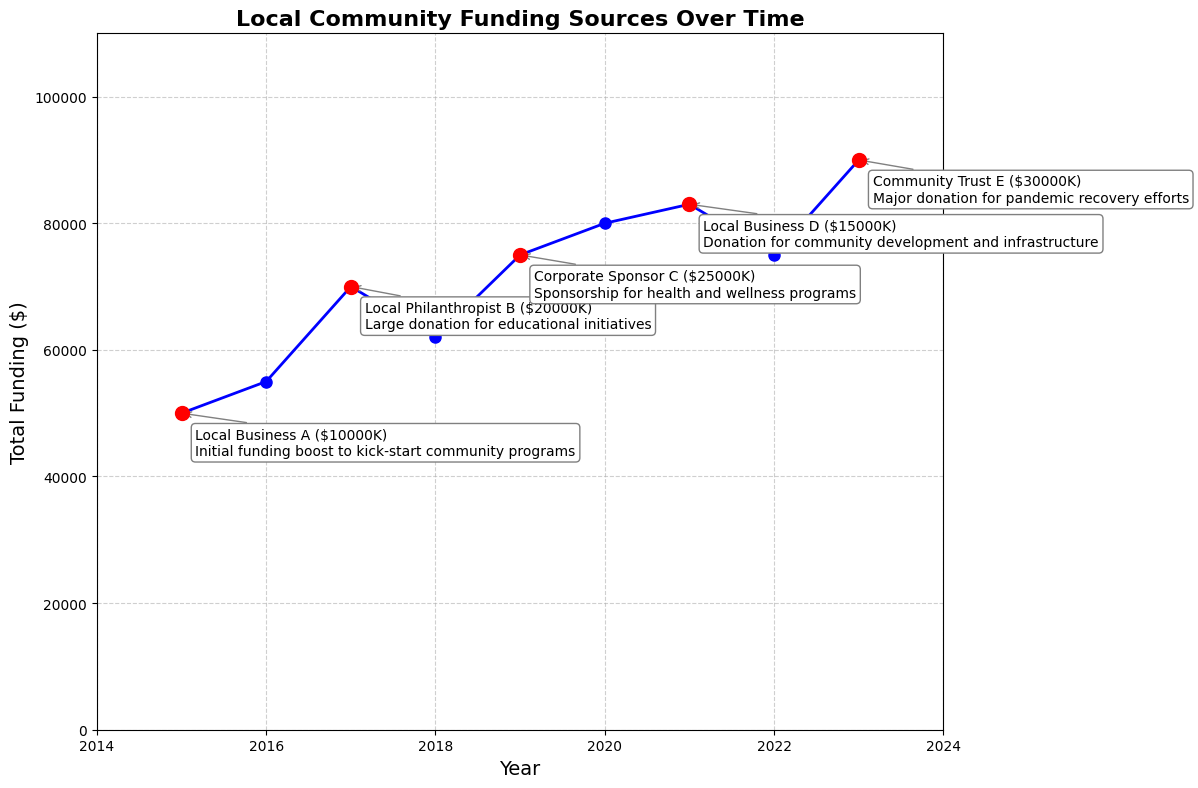How many years experienced a significant drop in total funding from the previous year? To determine this, we assess the year-over-year changes in total funding and count the instances where there is a drop. 2018, 2022 are the years where 62000 < 70000 (2018 < 2017) and 75000 < 83000 (2022 < 2021).
Answer: 2 Which year had the highest total funding without a significant donor? To find this, identify the years with "None" in the SignificantDonor column and compare their TotalFunding values. The year 2020 had the highest total funding without a significant donor with $80000.
Answer: 2020 In which year did Local Philanthropist B make a donation and how much was it? Look for the significant donor "Local Philanthropist B" and check the corresponding year and donation amount. Local Philanthropist B made a donation in 2017, with an amount of $20000.
Answer: 2017 and $20000 What is the difference in total funding between 2017 and 2018? Subtract the total funding of 2018 from 2017. The difference is 70000 - 62000 = $8000.
Answer: $8000 Compare the donation amounts made by significant donors in 2019 and 2023. Which year saw a higher individual donation? Check the donation amounts for the years 2019 and 2023. 2019 had $25000, and 2023 had $30000. 2023 saw a higher individual donation.
Answer: 2023 What was the trend in total funding from 2015 to 2016 and did it involve a significant donor? Observe the increase from 2015 ($50000) to 2016 ($55000). Since "SignificantDonor" is "None" for both years, this trend did not involve a significant donor.
Answer: Increase, no significant donor How much total funding was contributed by significant donors over the 9-year period? Sum up all the DonationAmount values from significant donors: $10000 (2015) + $20000 (2017) + $25000 (2019) + $15000 (2021) + $30000 (2023) = $100000.
Answer: $100000 Which significant donation was made for "pandemic recovery efforts" and in what year? Look for the note "pandemic recovery efforts" and find the corresponding year and donor. The Community Trust E made a $30000 donation in 2023 for pandemic recovery efforts.
Answer: Community Trust E in 2023, $30000 What is the average total funding for the years with significant donors? Calculate the average of the TotalFunding values for the years with significant donations: (50000 + 70000 + 75000 + 83000 + 90000) / 5 = 368000 / 5 = $73600.
Answer: $73600 How does the funding trend in 2020 compare visually to other years without significant donations? Visually compare the line heights and markers for 2020 with other "None" years. The year 2020 stands out with a peak at $80000, higher than other non-significant-donor years (2016, 2018, 2022).
Answer: 2020 is the highest 